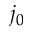<formula> <loc_0><loc_0><loc_500><loc_500>j _ { 0 }</formula> 